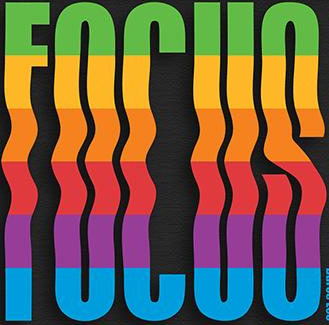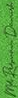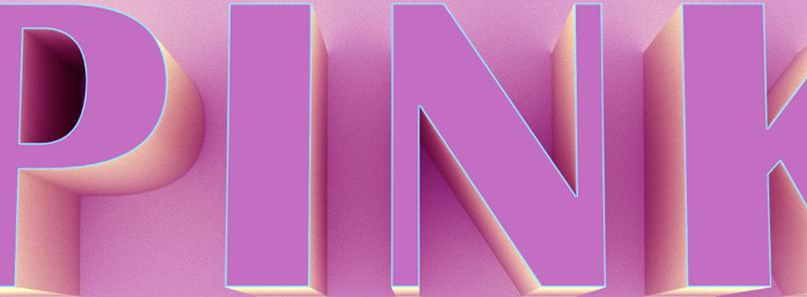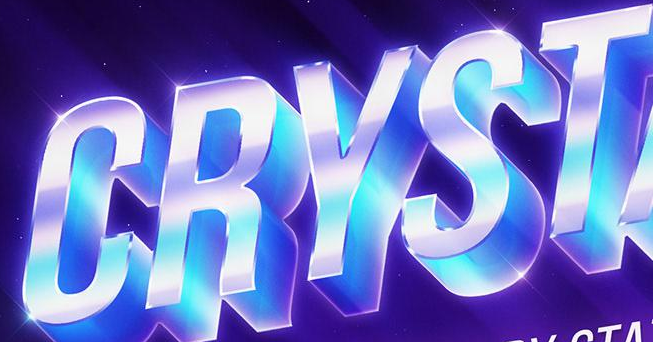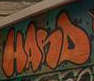Identify the words shown in these images in order, separated by a semicolon. FOCUS; #; PINK; CRYST; HANS 